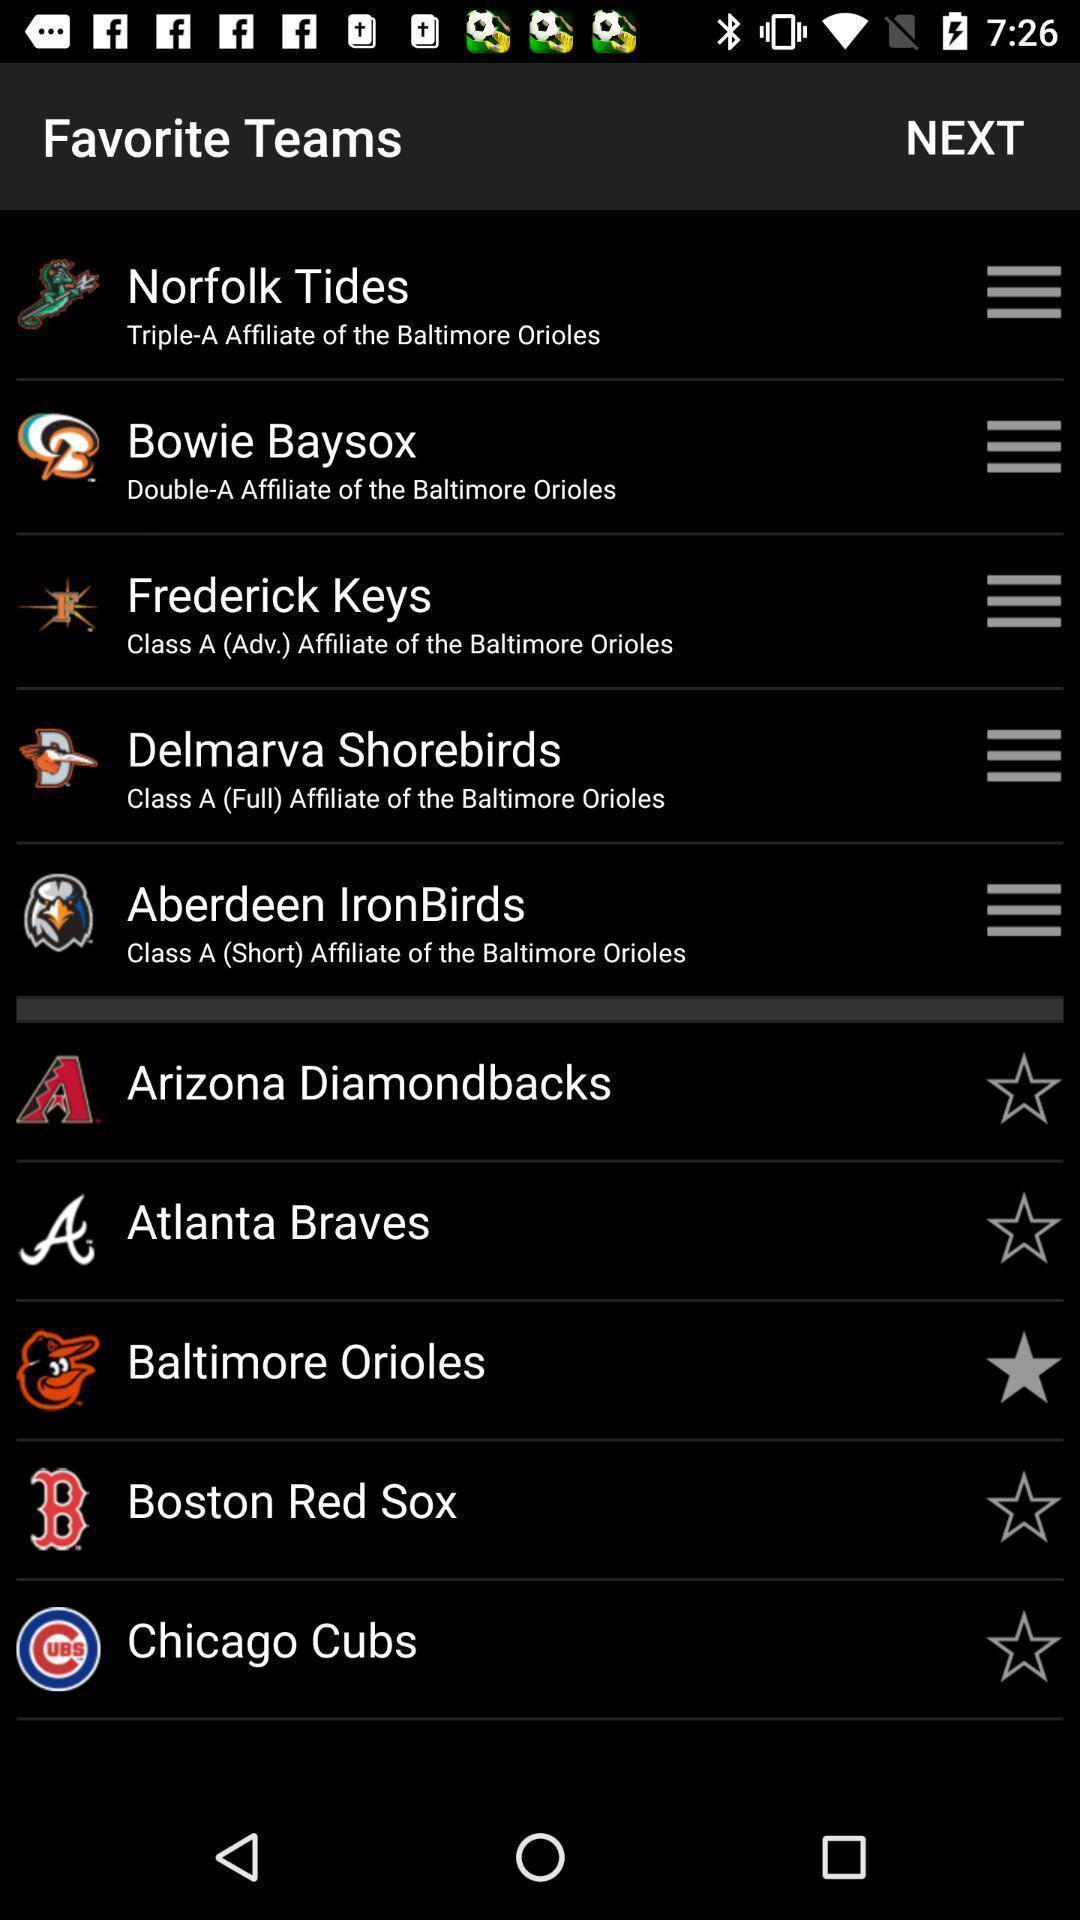Please provide a description for this image. Screen shows list of favorite teams. 